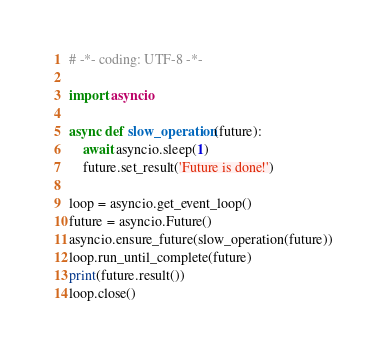Convert code to text. <code><loc_0><loc_0><loc_500><loc_500><_Python_># -*- coding: UTF-8 -*-

import asyncio

async def slow_operation(future):
    await asyncio.sleep(1)
    future.set_result('Future is done!')

loop = asyncio.get_event_loop()
future = asyncio.Future()
asyncio.ensure_future(slow_operation(future))
loop.run_until_complete(future)
print(future.result())
loop.close()
</code> 